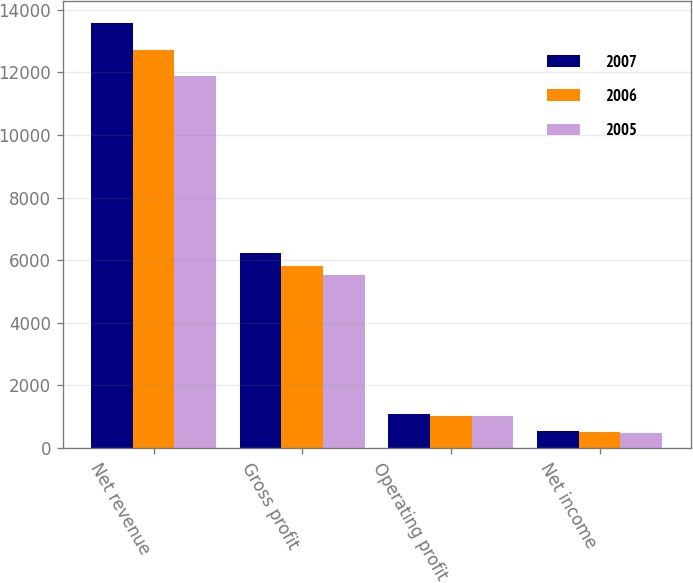Convert chart. <chart><loc_0><loc_0><loc_500><loc_500><stacked_bar_chart><ecel><fcel>Net revenue<fcel>Gross profit<fcel>Operating profit<fcel>Net income<nl><fcel>2007<fcel>13591<fcel>6221<fcel>1071<fcel>532<nl><fcel>2006<fcel>12730<fcel>5830<fcel>1017<fcel>522<nl><fcel>2005<fcel>11885<fcel>5540<fcel>1023<fcel>466<nl></chart> 